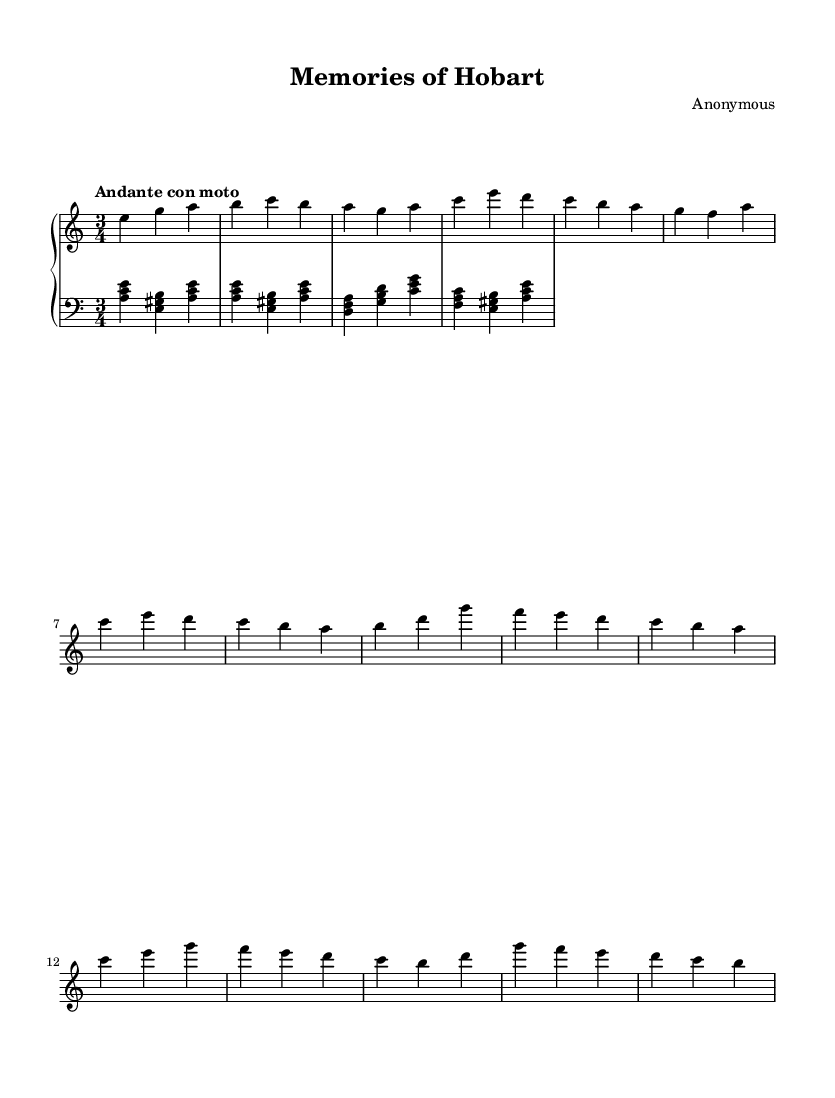What is the key signature of this music? The key signature is indicated by the sharps or flats at the beginning of the staff. In this case, there are no sharps or flats, which corresponds to A minor (the relative minor of C major).
Answer: A minor What is the time signature of this music? The time signature is noted at the beginning of the staff with two numbers, one above the other. Here, the top number is 3 and the bottom number is 4, indicating three beats per measure.
Answer: 3/4 What tempo marking is indicated in the music? The tempo marking is written above the notes, stating "Andante con moto," which means a moderately slow tempo with some motion.
Answer: Andante con moto How many measures are present in the right hand part? By counting the vertical bars that separate the music into sections (measures), we find there are a total of eight measures in the right hand part.
Answer: Eight What is the pattern of the left hand accompaniment? The left hand consists of broken chords that create an arpeggiated texture. Each measure follows a pattern of triads based on A minor, E major, D minor, and G major chords.
Answer: Broken chords How does the right hand melody relate to the left hand harmony? The right hand melody primarily utilizes notes found within the chords played by the left hand, creating consonance and a harmonious texture. This relationship emphasizes the tonality of A minor and gives a cohesive sound.
Answer: Consonance What is the overall mood of this piano piece? The piece is characterized by a reflective and sentimental quality, typical of Romantic-era music, often evoking feelings of nostalgia through its melodic phrasing and harmonic structure.
Answer: Reflective 